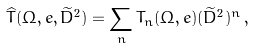<formula> <loc_0><loc_0><loc_500><loc_500>\widehat { T } ( \Omega , { e } , \widetilde { D } ^ { 2 } ) = \sum _ { n } T _ { n } ( \Omega , { e } ) ( \widetilde { D } ^ { 2 } ) ^ { n } \, ,</formula> 